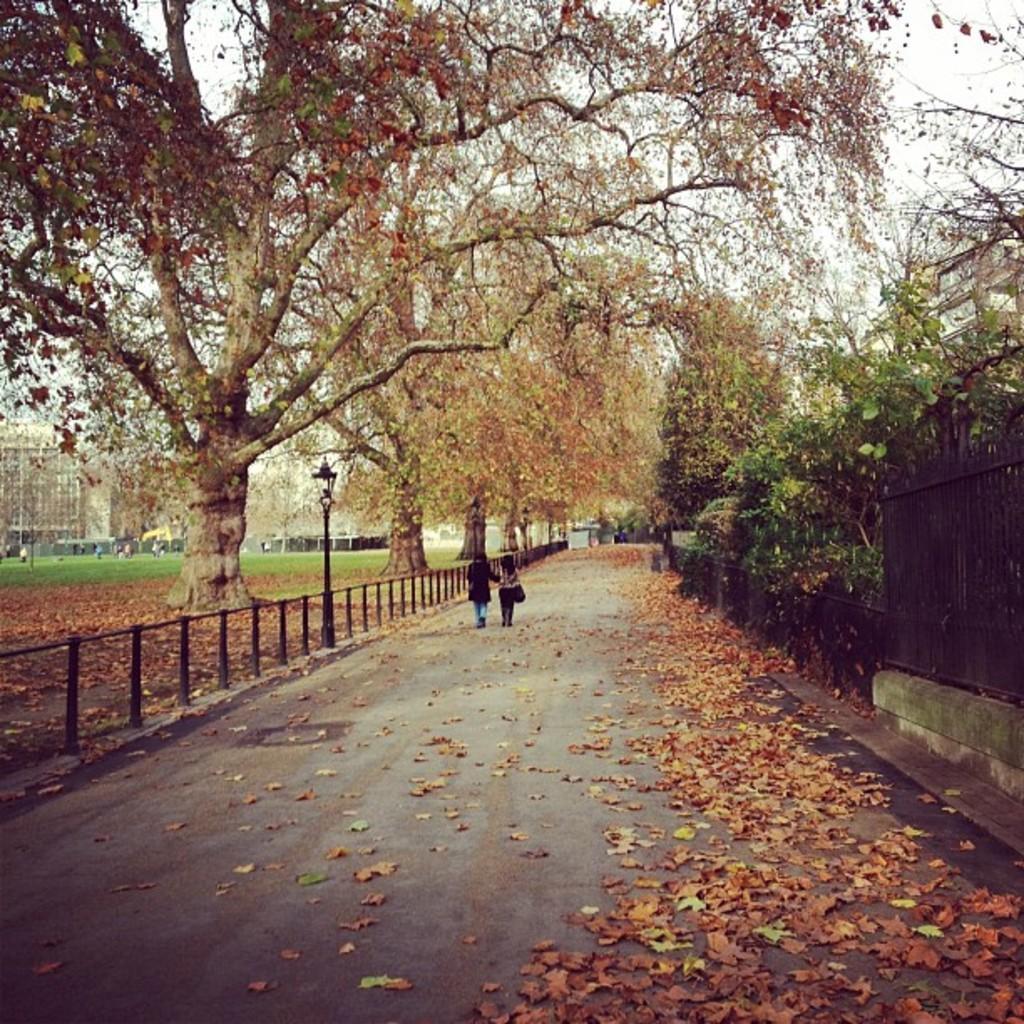Can you describe this image briefly? In this image I can see two persons walking, few light poles, trees in green color, buildings in white color. Background I can also see few other persons walking and the sky is in white color. 